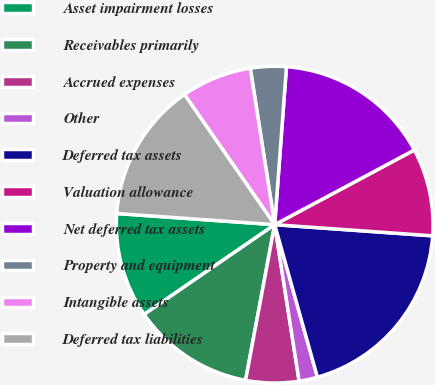<chart> <loc_0><loc_0><loc_500><loc_500><pie_chart><fcel>Asset impairment losses<fcel>Receivables primarily<fcel>Accrued expenses<fcel>Other<fcel>Deferred tax assets<fcel>Valuation allowance<fcel>Net deferred tax assets<fcel>Property and equipment<fcel>Intangible assets<fcel>Deferred tax liabilities<nl><fcel>10.71%<fcel>12.47%<fcel>5.41%<fcel>1.88%<fcel>19.53%<fcel>8.94%<fcel>16.0%<fcel>3.65%<fcel>7.18%<fcel>14.23%<nl></chart> 